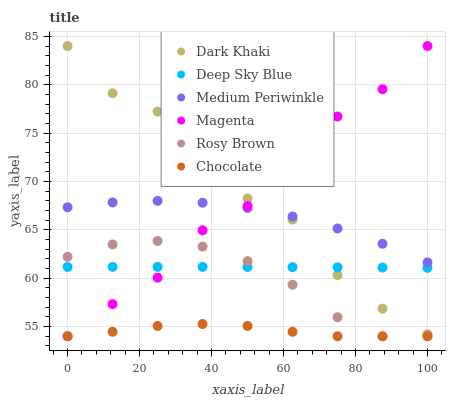Does Chocolate have the minimum area under the curve?
Answer yes or no. Yes. Does Dark Khaki have the maximum area under the curve?
Answer yes or no. Yes. Does Medium Periwinkle have the minimum area under the curve?
Answer yes or no. No. Does Medium Periwinkle have the maximum area under the curve?
Answer yes or no. No. Is Deep Sky Blue the smoothest?
Answer yes or no. Yes. Is Dark Khaki the roughest?
Answer yes or no. Yes. Is Medium Periwinkle the smoothest?
Answer yes or no. No. Is Medium Periwinkle the roughest?
Answer yes or no. No. Does Rosy Brown have the lowest value?
Answer yes or no. Yes. Does Medium Periwinkle have the lowest value?
Answer yes or no. No. Does Magenta have the highest value?
Answer yes or no. Yes. Does Medium Periwinkle have the highest value?
Answer yes or no. No. Is Rosy Brown less than Dark Khaki?
Answer yes or no. Yes. Is Deep Sky Blue greater than Chocolate?
Answer yes or no. Yes. Does Rosy Brown intersect Deep Sky Blue?
Answer yes or no. Yes. Is Rosy Brown less than Deep Sky Blue?
Answer yes or no. No. Is Rosy Brown greater than Deep Sky Blue?
Answer yes or no. No. Does Rosy Brown intersect Dark Khaki?
Answer yes or no. No. 